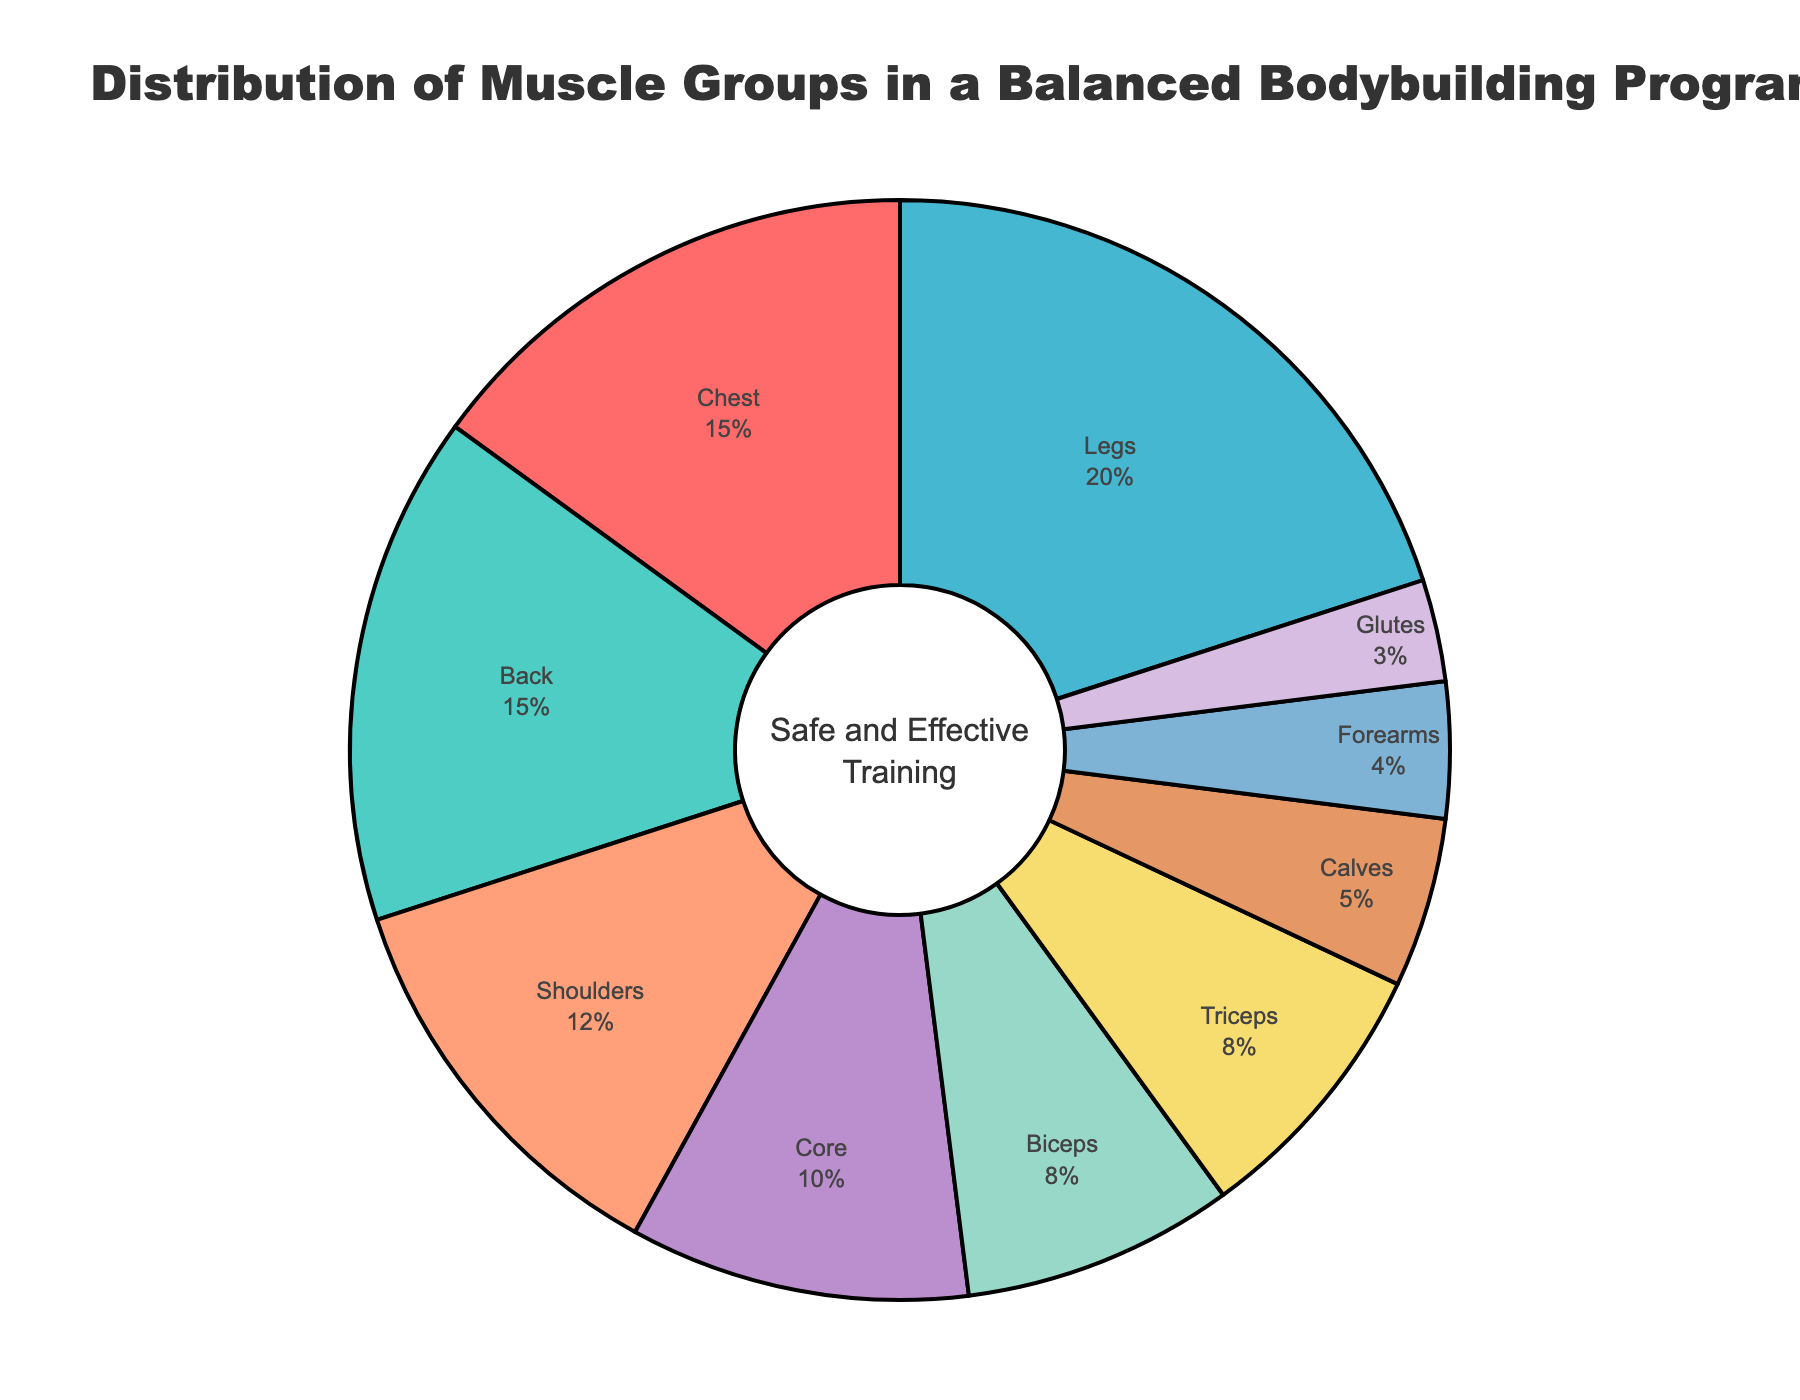What is the muscle group targeted the most in this bodybuilding program? According to the pie chart, legs are targeted the most with a percentage of 20%.
Answer: Legs Which muscle groups have equal training emphasis in the program? The muscle groups back and chest have equal emphasis, each with a percentage of 15%.
Answer: Back and chest What is the combined percentage of the muscle groups that are targeted less than 10%? The muscle groups targeted less than 10% are biceps (8%), triceps (8%), forearms (4%), calves (5%), and glutes (3%). Summing these values: 8 + 8 + 4 + 5 + 3 = 28%.
Answer: 28% How much more percentage is spent on legs compared to shoulders? The percentage for legs is 20% and for shoulders is 12%. The difference is 20% - 12% = 8%.
Answer: 8% Which muscle group has a slightly higher percentage of training than the core? The forearms have a slightly higher percentage of training than the core; forearms have 4% compared to the core's 10%.
Answer: Core How do the combined percentages of upper body muscle groups (chest, back, shoulders, biceps, triceps, forearms) compare to lower body muscle groups (legs, calves, glutes)? Upper body muscle groups: chest (15%), back (15%), shoulders (12%), biceps (8%), triceps (8%), forearms (4%). Combined: 15 + 15 + 12 + 8 + 8 + 4 = 62%. Lower body muscle groups: legs (20%), calves (5%), glutes (3%). Combined: 20 + 5 + 3 = 28%. The upper body receives more training at 62% compared to the lower body's 28%.
Answer: Upper body (62%) vs Lower body (28%) How many muscle groups make up one-third of the total training percentage? One-third of 100% is approximately 33.33%. The groups that add up to this value are shoulders (12%), core (10%), forearms (4%), and calves (5%). Summing these values: 12 + 10 + 4 + 5 = 31%.
Answer: Shoulders, Core, Forearms, Calves Which muscle group has the smallest percentage in the program, and what is its exact percentage? Glutes have the smallest percentage of training effort, which is 3%.
Answer: Glutes (3%) What is the collective percentage of the three least targeted muscle groups? The least targeted groups are glutes (3%), forearms (4%), and calves (5%). Summing these values: 3 + 4 + 5 = 12%.
Answer: 12% 